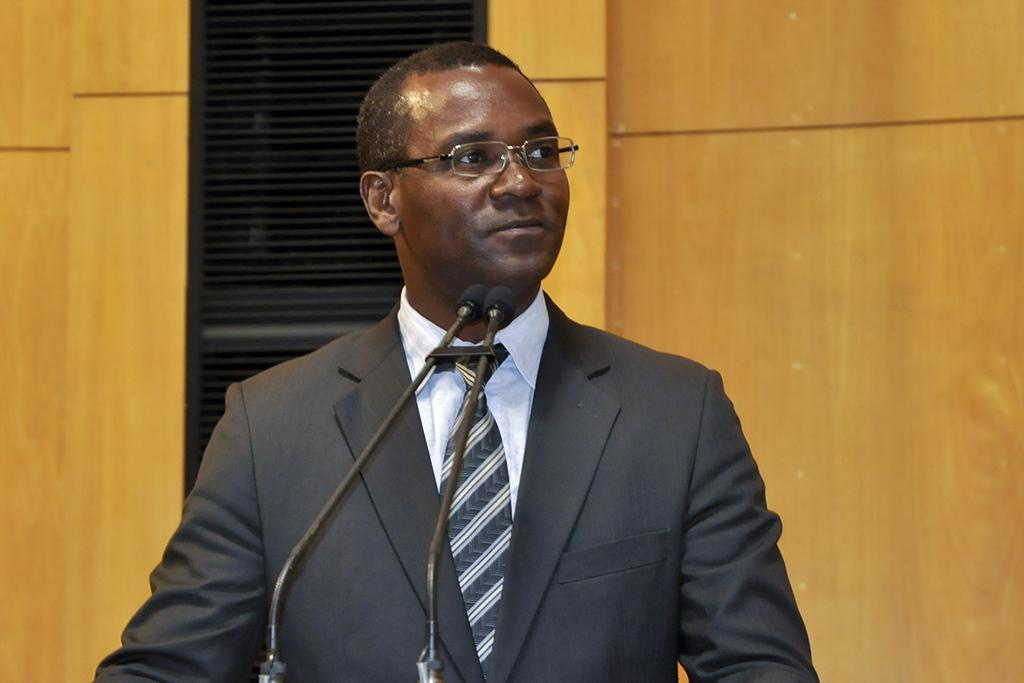Who is present in the image? There is a man in the image. What is the man wearing? The man is wearing a black suit and a tie. What objects are in front of the man? There are two microphones in front of the man. What can be seen in the background of the image? There is a wall in the background of the image. What material is the wall made of? The wall appears to be made of wood. Can you taste the wood from the wall in the image? No, you cannot taste the wood from the wall in the image, as it is a two-dimensional representation and not a physical object. 